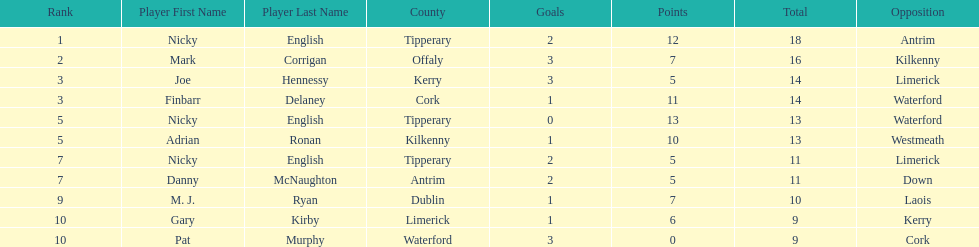How many times was waterford the opposition? 2. 